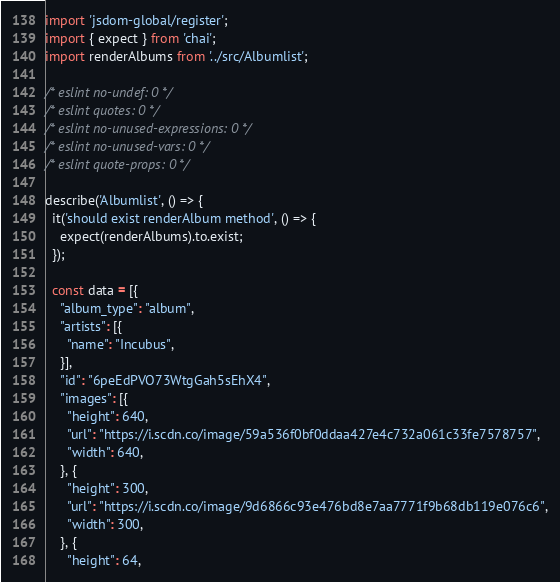<code> <loc_0><loc_0><loc_500><loc_500><_JavaScript_>import 'jsdom-global/register';
import { expect } from 'chai';
import renderAlbums from '../src/Albumlist';

/* eslint no-undef: 0 */
/* eslint quotes: 0 */
/* eslint no-unused-expressions: 0 */
/* eslint no-unused-vars: 0 */
/* eslint quote-props: 0 */

describe('Albumlist', () => {
  it('should exist renderAlbum method', () => {
    expect(renderAlbums).to.exist;
  });

  const data = [{
    "album_type": "album",
    "artists": [{
      "name": "Incubus",
    }],
    "id": "6peEdPVO73WtgGah5sEhX4",
    "images": [{
      "height": 640,
      "url": "https://i.scdn.co/image/59a536f0bf0ddaa427e4c732a061c33fe7578757",
      "width": 640,
    }, {
      "height": 300,
      "url": "https://i.scdn.co/image/9d6866c93e476bd8e7aa7771f9b68db119e076c6",
      "width": 300,
    }, {
      "height": 64,</code> 